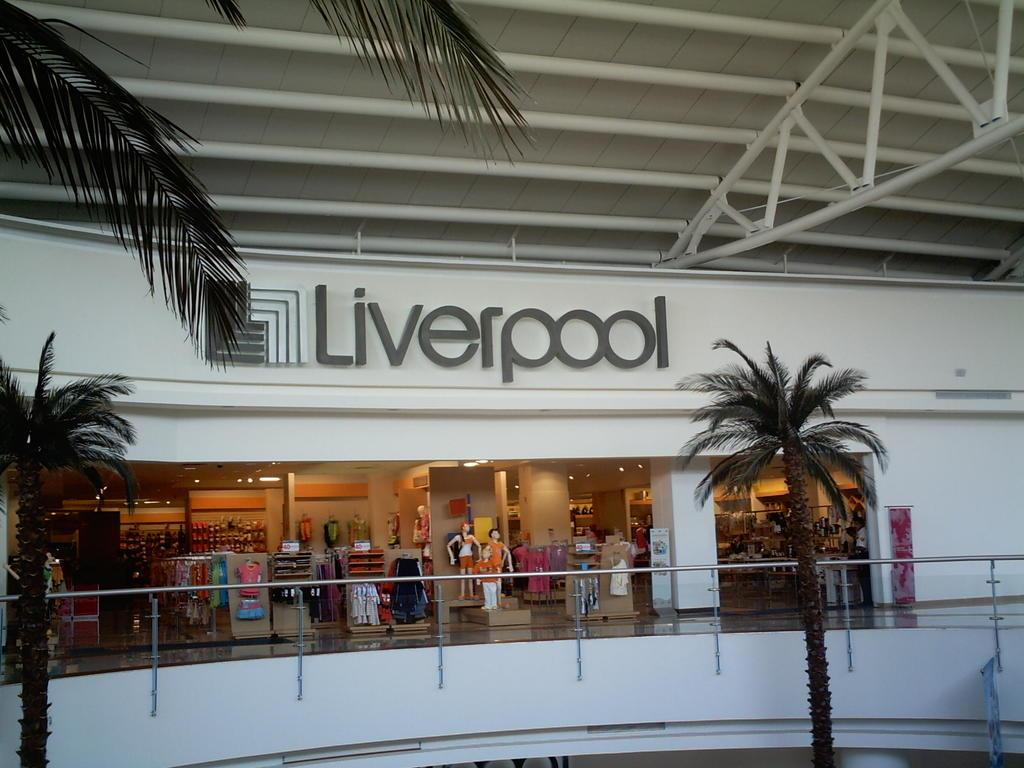What type of establishment is depicted in the image? There is a shop in the image. What can be seen on the wall of the shop? The name of the shop is visible on the wall. What is the color of the wall in the image? The wall in the image is white. What type of natural elements are present in the image? There are trees in the image. What year did the shop's aunt open the business? There is no mention of an aunt or a specific year in the image, so this information cannot be determined. 